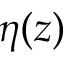<formula> <loc_0><loc_0><loc_500><loc_500>\eta ( z )</formula> 